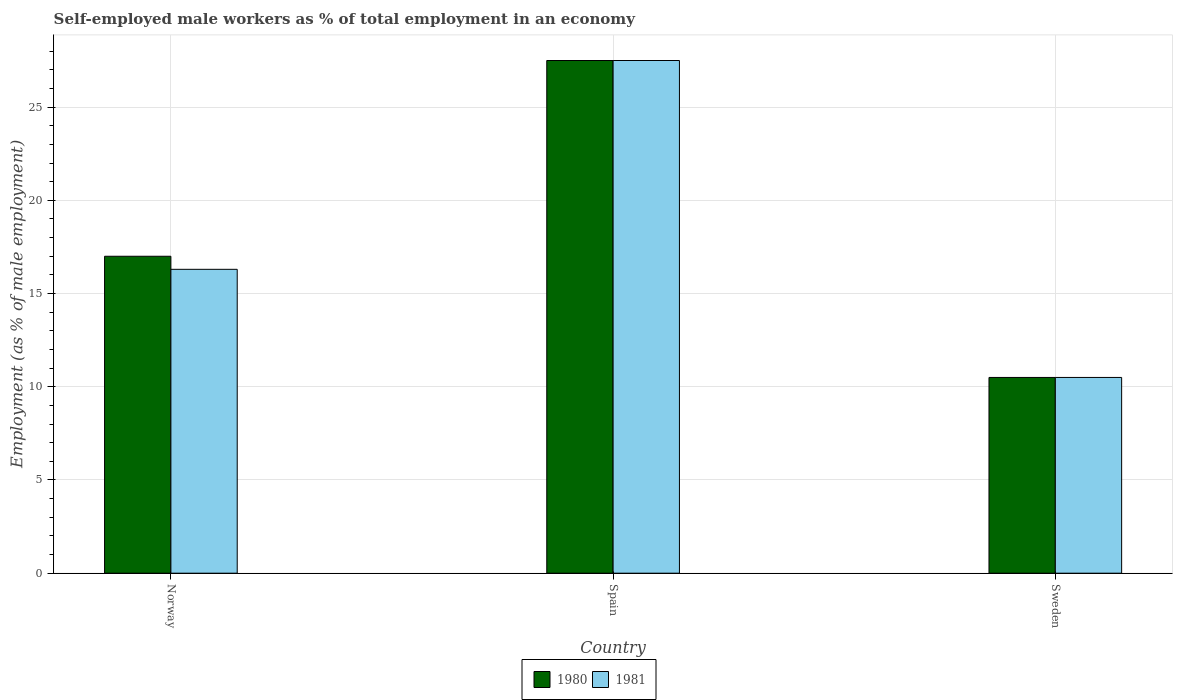How many different coloured bars are there?
Provide a short and direct response. 2. How many groups of bars are there?
Offer a terse response. 3. Are the number of bars on each tick of the X-axis equal?
Your answer should be very brief. Yes. How many bars are there on the 1st tick from the left?
Keep it short and to the point. 2. How many bars are there on the 3rd tick from the right?
Provide a succinct answer. 2. In how many cases, is the number of bars for a given country not equal to the number of legend labels?
Keep it short and to the point. 0. What is the percentage of self-employed male workers in 1980 in Norway?
Your answer should be compact. 17. Across all countries, what is the minimum percentage of self-employed male workers in 1980?
Your answer should be very brief. 10.5. What is the total percentage of self-employed male workers in 1981 in the graph?
Your answer should be compact. 54.3. What is the difference between the percentage of self-employed male workers in 1981 in Norway and that in Spain?
Give a very brief answer. -11.2. What is the difference between the percentage of self-employed male workers in 1981 in Sweden and the percentage of self-employed male workers in 1980 in Norway?
Offer a very short reply. -6.5. What is the average percentage of self-employed male workers in 1980 per country?
Provide a succinct answer. 18.33. What is the difference between the percentage of self-employed male workers of/in 1980 and percentage of self-employed male workers of/in 1981 in Sweden?
Your answer should be very brief. 0. In how many countries, is the percentage of self-employed male workers in 1981 greater than 14 %?
Make the answer very short. 2. What is the ratio of the percentage of self-employed male workers in 1980 in Norway to that in Spain?
Make the answer very short. 0.62. Is the percentage of self-employed male workers in 1980 in Norway less than that in Spain?
Offer a terse response. Yes. What is the difference between the highest and the second highest percentage of self-employed male workers in 1981?
Your answer should be very brief. 5.8. What does the 1st bar from the left in Spain represents?
Keep it short and to the point. 1980. How many bars are there?
Provide a short and direct response. 6. Are all the bars in the graph horizontal?
Your answer should be compact. No. Where does the legend appear in the graph?
Ensure brevity in your answer.  Bottom center. What is the title of the graph?
Give a very brief answer. Self-employed male workers as % of total employment in an economy. What is the label or title of the Y-axis?
Keep it short and to the point. Employment (as % of male employment). What is the Employment (as % of male employment) in 1980 in Norway?
Offer a very short reply. 17. What is the Employment (as % of male employment) in 1981 in Norway?
Your response must be concise. 16.3. What is the Employment (as % of male employment) in 1980 in Spain?
Your response must be concise. 27.5. What is the Employment (as % of male employment) in 1980 in Sweden?
Offer a terse response. 10.5. Across all countries, what is the maximum Employment (as % of male employment) in 1980?
Your response must be concise. 27.5. Across all countries, what is the minimum Employment (as % of male employment) in 1980?
Provide a short and direct response. 10.5. Across all countries, what is the minimum Employment (as % of male employment) in 1981?
Give a very brief answer. 10.5. What is the total Employment (as % of male employment) of 1981 in the graph?
Provide a short and direct response. 54.3. What is the difference between the Employment (as % of male employment) in 1981 in Norway and that in Spain?
Your response must be concise. -11.2. What is the difference between the Employment (as % of male employment) in 1980 in Norway and that in Sweden?
Provide a short and direct response. 6.5. What is the difference between the Employment (as % of male employment) of 1981 in Norway and that in Sweden?
Offer a very short reply. 5.8. What is the difference between the Employment (as % of male employment) of 1980 in Spain and that in Sweden?
Provide a short and direct response. 17. What is the difference between the Employment (as % of male employment) of 1981 in Spain and that in Sweden?
Your response must be concise. 17. What is the difference between the Employment (as % of male employment) of 1980 in Norway and the Employment (as % of male employment) of 1981 in Spain?
Ensure brevity in your answer.  -10.5. What is the difference between the Employment (as % of male employment) of 1980 in Norway and the Employment (as % of male employment) of 1981 in Sweden?
Offer a terse response. 6.5. What is the average Employment (as % of male employment) in 1980 per country?
Offer a very short reply. 18.33. What is the difference between the Employment (as % of male employment) in 1980 and Employment (as % of male employment) in 1981 in Norway?
Provide a short and direct response. 0.7. What is the difference between the Employment (as % of male employment) in 1980 and Employment (as % of male employment) in 1981 in Spain?
Offer a very short reply. 0. What is the difference between the Employment (as % of male employment) in 1980 and Employment (as % of male employment) in 1981 in Sweden?
Your answer should be compact. 0. What is the ratio of the Employment (as % of male employment) in 1980 in Norway to that in Spain?
Provide a succinct answer. 0.62. What is the ratio of the Employment (as % of male employment) in 1981 in Norway to that in Spain?
Your response must be concise. 0.59. What is the ratio of the Employment (as % of male employment) of 1980 in Norway to that in Sweden?
Offer a very short reply. 1.62. What is the ratio of the Employment (as % of male employment) of 1981 in Norway to that in Sweden?
Make the answer very short. 1.55. What is the ratio of the Employment (as % of male employment) in 1980 in Spain to that in Sweden?
Provide a succinct answer. 2.62. What is the ratio of the Employment (as % of male employment) of 1981 in Spain to that in Sweden?
Your answer should be very brief. 2.62. What is the difference between the highest and the lowest Employment (as % of male employment) of 1981?
Give a very brief answer. 17. 